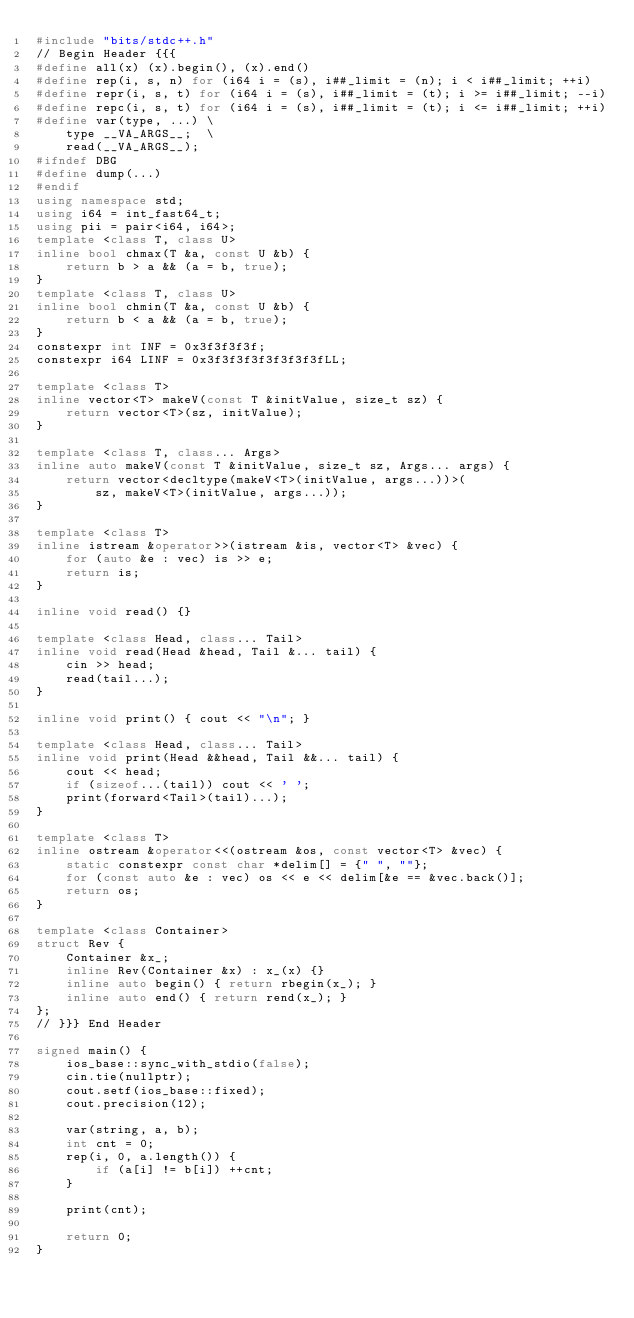Convert code to text. <code><loc_0><loc_0><loc_500><loc_500><_C++_>#include "bits/stdc++.h"
// Begin Header {{{
#define all(x) (x).begin(), (x).end()
#define rep(i, s, n) for (i64 i = (s), i##_limit = (n); i < i##_limit; ++i)
#define repr(i, s, t) for (i64 i = (s), i##_limit = (t); i >= i##_limit; --i)
#define repc(i, s, t) for (i64 i = (s), i##_limit = (t); i <= i##_limit; ++i)
#define var(type, ...) \
    type __VA_ARGS__;  \
    read(__VA_ARGS__);
#ifndef DBG
#define dump(...)
#endif
using namespace std;
using i64 = int_fast64_t;
using pii = pair<i64, i64>;
template <class T, class U>
inline bool chmax(T &a, const U &b) {
    return b > a && (a = b, true);
}
template <class T, class U>
inline bool chmin(T &a, const U &b) {
    return b < a && (a = b, true);
}
constexpr int INF = 0x3f3f3f3f;
constexpr i64 LINF = 0x3f3f3f3f3f3f3f3fLL;

template <class T>
inline vector<T> makeV(const T &initValue, size_t sz) {
    return vector<T>(sz, initValue);
}

template <class T, class... Args>
inline auto makeV(const T &initValue, size_t sz, Args... args) {
    return vector<decltype(makeV<T>(initValue, args...))>(
        sz, makeV<T>(initValue, args...));
}

template <class T>
inline istream &operator>>(istream &is, vector<T> &vec) {
    for (auto &e : vec) is >> e;
    return is;
}

inline void read() {}

template <class Head, class... Tail>
inline void read(Head &head, Tail &... tail) {
    cin >> head;
    read(tail...);
}

inline void print() { cout << "\n"; }

template <class Head, class... Tail>
inline void print(Head &&head, Tail &&... tail) {
    cout << head;
    if (sizeof...(tail)) cout << ' ';
    print(forward<Tail>(tail)...);
}

template <class T>
inline ostream &operator<<(ostream &os, const vector<T> &vec) {
    static constexpr const char *delim[] = {" ", ""};
    for (const auto &e : vec) os << e << delim[&e == &vec.back()];
    return os;
}

template <class Container>
struct Rev {
    Container &x_;
    inline Rev(Container &x) : x_(x) {}
    inline auto begin() { return rbegin(x_); }
    inline auto end() { return rend(x_); }
};
// }}} End Header

signed main() {
    ios_base::sync_with_stdio(false);
    cin.tie(nullptr);
    cout.setf(ios_base::fixed);
    cout.precision(12);

    var(string, a, b);
    int cnt = 0;
    rep(i, 0, a.length()) {
        if (a[i] != b[i]) ++cnt;
    }

    print(cnt);

    return 0;
}
</code> 